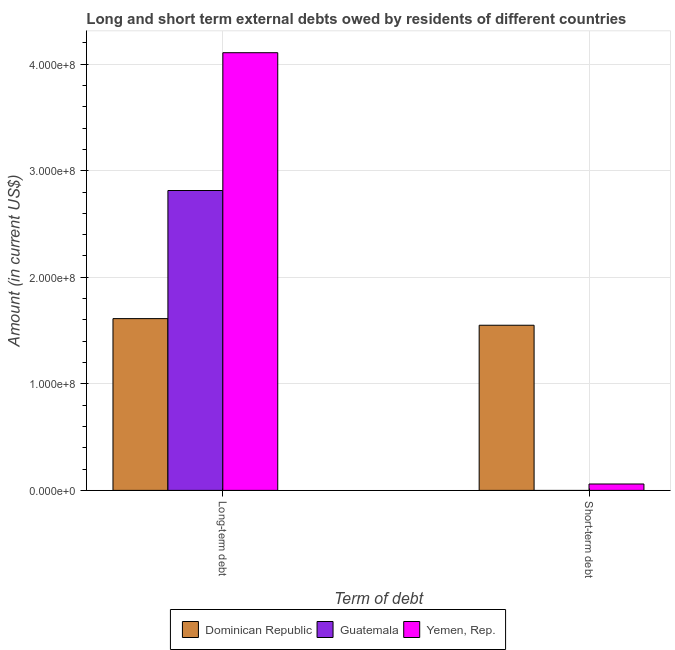Are the number of bars per tick equal to the number of legend labels?
Ensure brevity in your answer.  No. How many bars are there on the 2nd tick from the left?
Your response must be concise. 2. How many bars are there on the 1st tick from the right?
Make the answer very short. 2. What is the label of the 2nd group of bars from the left?
Make the answer very short. Short-term debt. What is the long-term debts owed by residents in Yemen, Rep.?
Keep it short and to the point. 4.11e+08. Across all countries, what is the maximum short-term debts owed by residents?
Provide a short and direct response. 1.55e+08. Across all countries, what is the minimum long-term debts owed by residents?
Your response must be concise. 1.61e+08. In which country was the long-term debts owed by residents maximum?
Provide a succinct answer. Yemen, Rep. What is the total short-term debts owed by residents in the graph?
Keep it short and to the point. 1.61e+08. What is the difference between the long-term debts owed by residents in Dominican Republic and that in Guatemala?
Give a very brief answer. -1.20e+08. What is the difference between the short-term debts owed by residents in Yemen, Rep. and the long-term debts owed by residents in Guatemala?
Your answer should be compact. -2.75e+08. What is the average long-term debts owed by residents per country?
Ensure brevity in your answer.  2.84e+08. What is the difference between the short-term debts owed by residents and long-term debts owed by residents in Dominican Republic?
Your response must be concise. -6.21e+06. What is the ratio of the long-term debts owed by residents in Guatemala to that in Dominican Republic?
Provide a short and direct response. 1.75. Is the short-term debts owed by residents in Yemen, Rep. less than that in Dominican Republic?
Make the answer very short. Yes. In how many countries, is the long-term debts owed by residents greater than the average long-term debts owed by residents taken over all countries?
Offer a terse response. 1. How many bars are there?
Your answer should be compact. 5. Are all the bars in the graph horizontal?
Your response must be concise. No. Are the values on the major ticks of Y-axis written in scientific E-notation?
Make the answer very short. Yes. Where does the legend appear in the graph?
Ensure brevity in your answer.  Bottom center. How many legend labels are there?
Offer a very short reply. 3. What is the title of the graph?
Provide a succinct answer. Long and short term external debts owed by residents of different countries. Does "Niger" appear as one of the legend labels in the graph?
Provide a succinct answer. No. What is the label or title of the X-axis?
Make the answer very short. Term of debt. What is the Amount (in current US$) of Dominican Republic in Long-term debt?
Your answer should be very brief. 1.61e+08. What is the Amount (in current US$) of Guatemala in Long-term debt?
Your answer should be compact. 2.81e+08. What is the Amount (in current US$) of Yemen, Rep. in Long-term debt?
Offer a terse response. 4.11e+08. What is the Amount (in current US$) in Dominican Republic in Short-term debt?
Your answer should be very brief. 1.55e+08. Across all Term of debt, what is the maximum Amount (in current US$) of Dominican Republic?
Offer a very short reply. 1.61e+08. Across all Term of debt, what is the maximum Amount (in current US$) of Guatemala?
Offer a terse response. 2.81e+08. Across all Term of debt, what is the maximum Amount (in current US$) in Yemen, Rep.?
Your response must be concise. 4.11e+08. Across all Term of debt, what is the minimum Amount (in current US$) in Dominican Republic?
Provide a succinct answer. 1.55e+08. Across all Term of debt, what is the minimum Amount (in current US$) of Yemen, Rep.?
Your answer should be very brief. 6.00e+06. What is the total Amount (in current US$) of Dominican Republic in the graph?
Your answer should be compact. 3.16e+08. What is the total Amount (in current US$) of Guatemala in the graph?
Ensure brevity in your answer.  2.81e+08. What is the total Amount (in current US$) in Yemen, Rep. in the graph?
Ensure brevity in your answer.  4.17e+08. What is the difference between the Amount (in current US$) of Dominican Republic in Long-term debt and that in Short-term debt?
Provide a short and direct response. 6.21e+06. What is the difference between the Amount (in current US$) of Yemen, Rep. in Long-term debt and that in Short-term debt?
Your answer should be very brief. 4.05e+08. What is the difference between the Amount (in current US$) of Dominican Republic in Long-term debt and the Amount (in current US$) of Yemen, Rep. in Short-term debt?
Your answer should be very brief. 1.55e+08. What is the difference between the Amount (in current US$) in Guatemala in Long-term debt and the Amount (in current US$) in Yemen, Rep. in Short-term debt?
Make the answer very short. 2.75e+08. What is the average Amount (in current US$) of Dominican Republic per Term of debt?
Give a very brief answer. 1.58e+08. What is the average Amount (in current US$) of Guatemala per Term of debt?
Your response must be concise. 1.41e+08. What is the average Amount (in current US$) of Yemen, Rep. per Term of debt?
Ensure brevity in your answer.  2.08e+08. What is the difference between the Amount (in current US$) of Dominican Republic and Amount (in current US$) of Guatemala in Long-term debt?
Provide a short and direct response. -1.20e+08. What is the difference between the Amount (in current US$) of Dominican Republic and Amount (in current US$) of Yemen, Rep. in Long-term debt?
Offer a terse response. -2.50e+08. What is the difference between the Amount (in current US$) of Guatemala and Amount (in current US$) of Yemen, Rep. in Long-term debt?
Ensure brevity in your answer.  -1.29e+08. What is the difference between the Amount (in current US$) in Dominican Republic and Amount (in current US$) in Yemen, Rep. in Short-term debt?
Provide a short and direct response. 1.49e+08. What is the ratio of the Amount (in current US$) of Dominican Republic in Long-term debt to that in Short-term debt?
Offer a very short reply. 1.04. What is the ratio of the Amount (in current US$) of Yemen, Rep. in Long-term debt to that in Short-term debt?
Offer a terse response. 68.47. What is the difference between the highest and the second highest Amount (in current US$) of Dominican Republic?
Ensure brevity in your answer.  6.21e+06. What is the difference between the highest and the second highest Amount (in current US$) in Yemen, Rep.?
Your response must be concise. 4.05e+08. What is the difference between the highest and the lowest Amount (in current US$) in Dominican Republic?
Your answer should be compact. 6.21e+06. What is the difference between the highest and the lowest Amount (in current US$) in Guatemala?
Provide a succinct answer. 2.81e+08. What is the difference between the highest and the lowest Amount (in current US$) of Yemen, Rep.?
Offer a very short reply. 4.05e+08. 